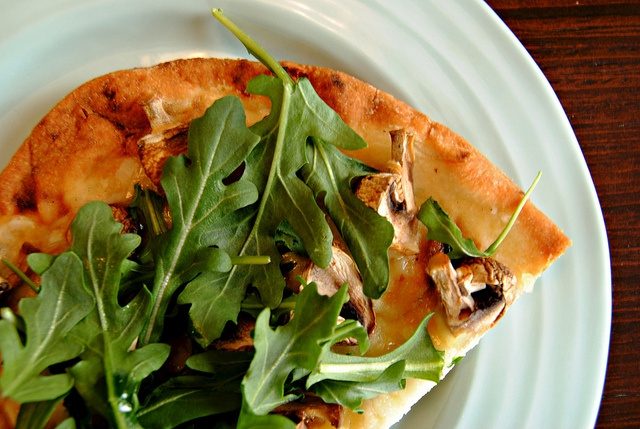Describe the objects in this image and their specific colors. I can see a pizza in lightgray, black, darkgreen, and red tones in this image. 